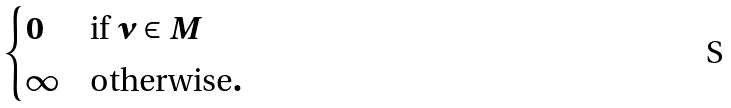Convert formula to latex. <formula><loc_0><loc_0><loc_500><loc_500>\begin{cases} 0 & \text {if } \nu \in M \\ \infty & \text {otherwise} . \end{cases}</formula> 